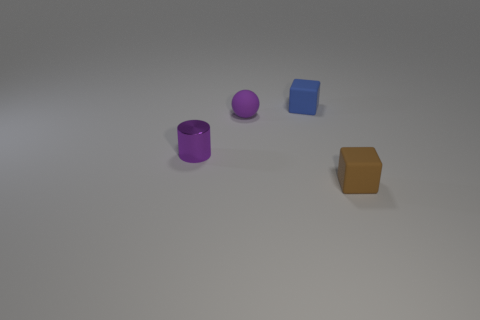Can you tell me what shapes are present in the image? Certainly! The image shows a collection of three-dimensional shapes: a purple cylinder, a spherical object in purple, and a blue cube, along with a brown rectangular prism. 